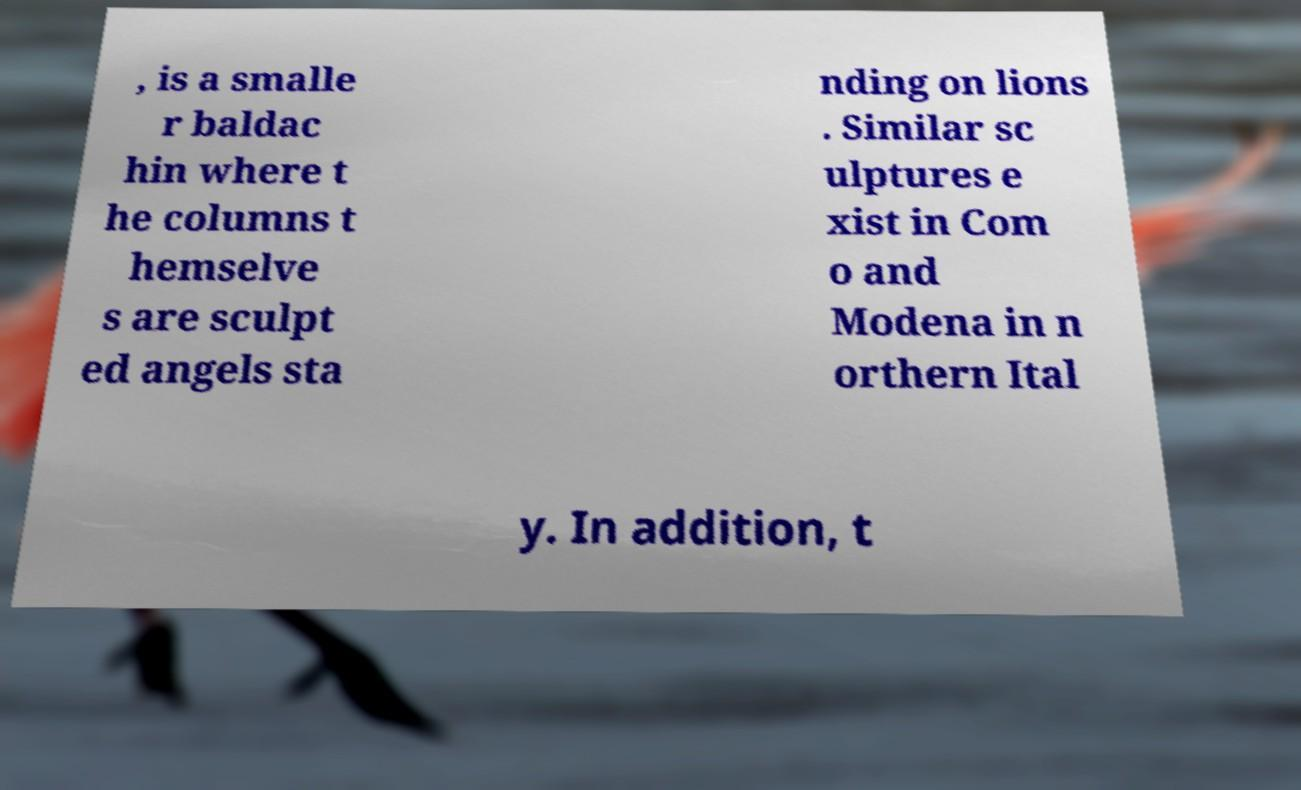Please read and relay the text visible in this image. What does it say? , is a smalle r baldac hin where t he columns t hemselve s are sculpt ed angels sta nding on lions . Similar sc ulptures e xist in Com o and Modena in n orthern Ital y. In addition, t 